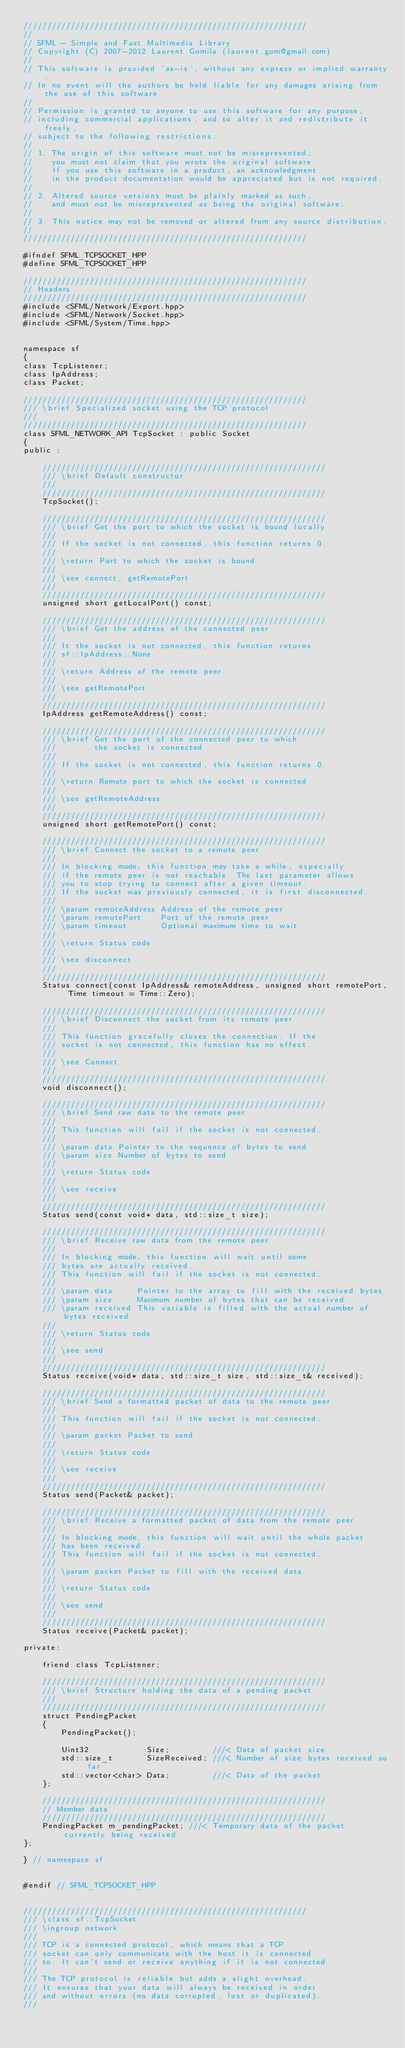Convert code to text. <code><loc_0><loc_0><loc_500><loc_500><_C++_>////////////////////////////////////////////////////////////
//
// SFML - Simple and Fast Multimedia Library
// Copyright (C) 2007-2012 Laurent Gomila (laurent.gom@gmail.com)
//
// This software is provided 'as-is', without any express or implied warranty.
// In no event will the authors be held liable for any damages arising from the use of this software.
//
// Permission is granted to anyone to use this software for any purpose,
// including commercial applications, and to alter it and redistribute it freely,
// subject to the following restrictions:
//
// 1. The origin of this software must not be misrepresented;
//    you must not claim that you wrote the original software.
//    If you use this software in a product, an acknowledgment
//    in the product documentation would be appreciated but is not required.
//
// 2. Altered source versions must be plainly marked as such,
//    and must not be misrepresented as being the original software.
//
// 3. This notice may not be removed or altered from any source distribution.
//
////////////////////////////////////////////////////////////

#ifndef SFML_TCPSOCKET_HPP
#define SFML_TCPSOCKET_HPP

////////////////////////////////////////////////////////////
// Headers
////////////////////////////////////////////////////////////
#include <SFML/Network/Export.hpp>
#include <SFML/Network/Socket.hpp>
#include <SFML/System/Time.hpp>


namespace sf
{
class TcpListener;
class IpAddress;
class Packet;

////////////////////////////////////////////////////////////
/// \brief Specialized socket using the TCP protocol
///
////////////////////////////////////////////////////////////
class SFML_NETWORK_API TcpSocket : public Socket
{
public :

    ////////////////////////////////////////////////////////////
    /// \brief Default constructor
    ///
    ////////////////////////////////////////////////////////////
    TcpSocket();

    ////////////////////////////////////////////////////////////
    /// \brief Get the port to which the socket is bound locally
    ///
    /// If the socket is not connected, this function returns 0.
    ///
    /// \return Port to which the socket is bound
    ///
    /// \see connect, getRemotePort
    ///
    ////////////////////////////////////////////////////////////
    unsigned short getLocalPort() const;

    ////////////////////////////////////////////////////////////
    /// \brief Get the address of the connected peer
    ///
    /// It the socket is not connected, this function returns
    /// sf::IpAddress::None.
    ///
    /// \return Address of the remote peer
    ///
    /// \see getRemotePort
    ///
    ////////////////////////////////////////////////////////////
    IpAddress getRemoteAddress() const;

    ////////////////////////////////////////////////////////////
    /// \brief Get the port of the connected peer to which
    ///        the socket is connected
    ///
    /// If the socket is not connected, this function returns 0.
    ///
    /// \return Remote port to which the socket is connected
    ///
    /// \see getRemoteAddress
    ///
    ////////////////////////////////////////////////////////////
    unsigned short getRemotePort() const;

    ////////////////////////////////////////////////////////////
    /// \brief Connect the socket to a remote peer
    ///
    /// In blocking mode, this function may take a while, especially
    /// if the remote peer is not reachable. The last parameter allows
    /// you to stop trying to connect after a given timeout.
    /// If the socket was previously connected, it is first disconnected.
    ///
    /// \param remoteAddress Address of the remote peer
    /// \param remotePort    Port of the remote peer
    /// \param timeout       Optional maximum time to wait
    ///
    /// \return Status code
    ///
    /// \see disconnect
    ///
    ////////////////////////////////////////////////////////////
    Status connect(const IpAddress& remoteAddress, unsigned short remotePort, Time timeout = Time::Zero);

    ////////////////////////////////////////////////////////////
    /// \brief Disconnect the socket from its remote peer
    ///
    /// This function gracefully closes the connection. If the
    /// socket is not connected, this function has no effect.
    ///
    /// \see Connect
    ///
    ////////////////////////////////////////////////////////////
    void disconnect();

    ////////////////////////////////////////////////////////////
    /// \brief Send raw data to the remote peer
    ///
    /// This function will fail if the socket is not connected.
    ///
    /// \param data Pointer to the sequence of bytes to send
    /// \param size Number of bytes to send
    ///
    /// \return Status code
    ///
    /// \see receive
    ///
    ////////////////////////////////////////////////////////////
    Status send(const void* data, std::size_t size);

    ////////////////////////////////////////////////////////////
    /// \brief Receive raw data from the remote peer
    ///
    /// In blocking mode, this function will wait until some
    /// bytes are actually received.
    /// This function will fail if the socket is not connected.
    ///
    /// \param data     Pointer to the array to fill with the received bytes
    /// \param size     Maximum number of bytes that can be received
    /// \param received This variable is filled with the actual number of bytes received
    ///
    /// \return Status code
    ///
    /// \see send
    ///
    ////////////////////////////////////////////////////////////
    Status receive(void* data, std::size_t size, std::size_t& received);

    ////////////////////////////////////////////////////////////
    /// \brief Send a formatted packet of data to the remote peer
    ///
    /// This function will fail if the socket is not connected.
    ///
    /// \param packet Packet to send
    ///
    /// \return Status code
    ///
    /// \see receive
    ///
    ////////////////////////////////////////////////////////////
    Status send(Packet& packet);

    ////////////////////////////////////////////////////////////
    /// \brief Receive a formatted packet of data from the remote peer
    ///
    /// In blocking mode, this function will wait until the whole packet
    /// has been received.
    /// This function will fail if the socket is not connected.
    ///
    /// \param packet Packet to fill with the received data
    ///
    /// \return Status code
    ///
    /// \see send
    ///
    ////////////////////////////////////////////////////////////
    Status receive(Packet& packet);

private:

    friend class TcpListener;

    ////////////////////////////////////////////////////////////
    /// \brief Structure holding the data of a pending packet
    ///
    ////////////////////////////////////////////////////////////
    struct PendingPacket
    {
        PendingPacket();

        Uint32            Size;         ///< Data of packet size
        std::size_t       SizeReceived; ///< Number of size bytes received so far
        std::vector<char> Data;         ///< Data of the packet
    };

    ////////////////////////////////////////////////////////////
    // Member data
    ////////////////////////////////////////////////////////////
    PendingPacket m_pendingPacket; ///< Temporary data of the packet currently being received
};

} // namespace sf


#endif // SFML_TCPSOCKET_HPP


////////////////////////////////////////////////////////////
/// \class sf::TcpSocket
/// \ingroup network
///
/// TCP is a connected protocol, which means that a TCP
/// socket can only communicate with the host it is connected
/// to. It can't send or receive anything if it is not connected.
///
/// The TCP protocol is reliable but adds a slight overhead.
/// It ensures that your data will always be received in order
/// and without errors (no data corrupted, lost or duplicated).
///</code> 